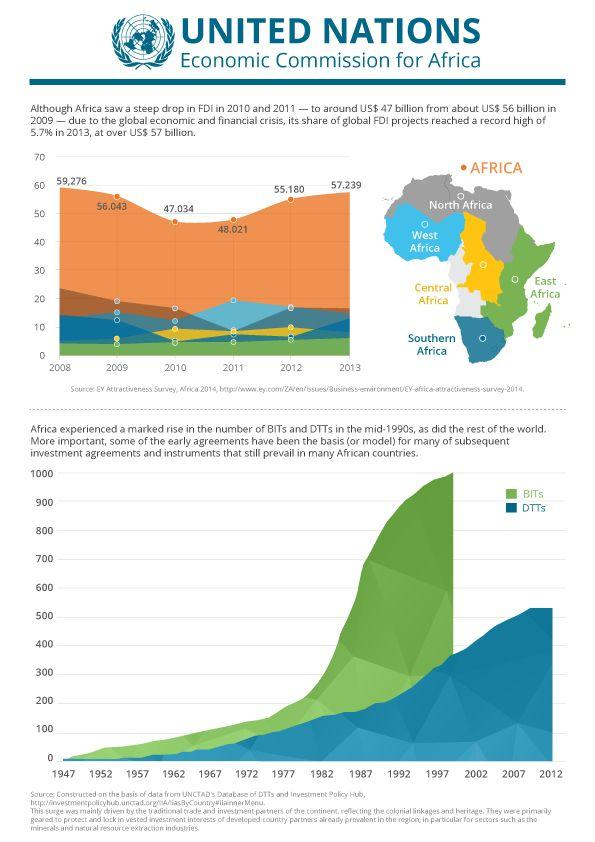Draw attention to some important aspects in this diagram. In 2010-2011, the amount of Foreign Direct Investment (FDI) in Africa decreased by $9 billion from the previous year, 2009. In 2011, the West African region made the highest contribution to Foreign Direct Investment (FDI). How many regions has Africa been divided into? There are 6 regions in total. The East African region has consistently demonstrated growth in foreign direct investment (FDI) from the year 2008 to 2013. 